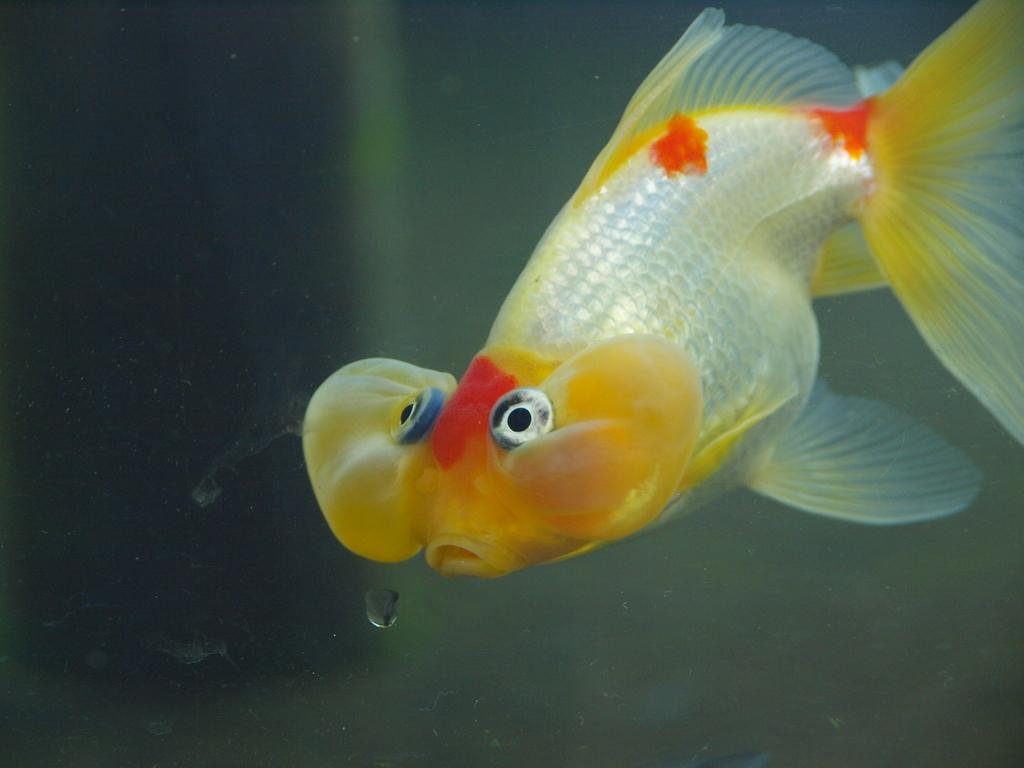What type of animal is in the image? There is a fish in the image. What can be seen near the fish in the image? There is a water drop in the image. What type of leather is visible in the image? There is no leather present in the image. What is the tendency of the fish to participate in competitions in the image? The image does not show any indication of the fish participating in competitions, so it cannot be determined from the image. 